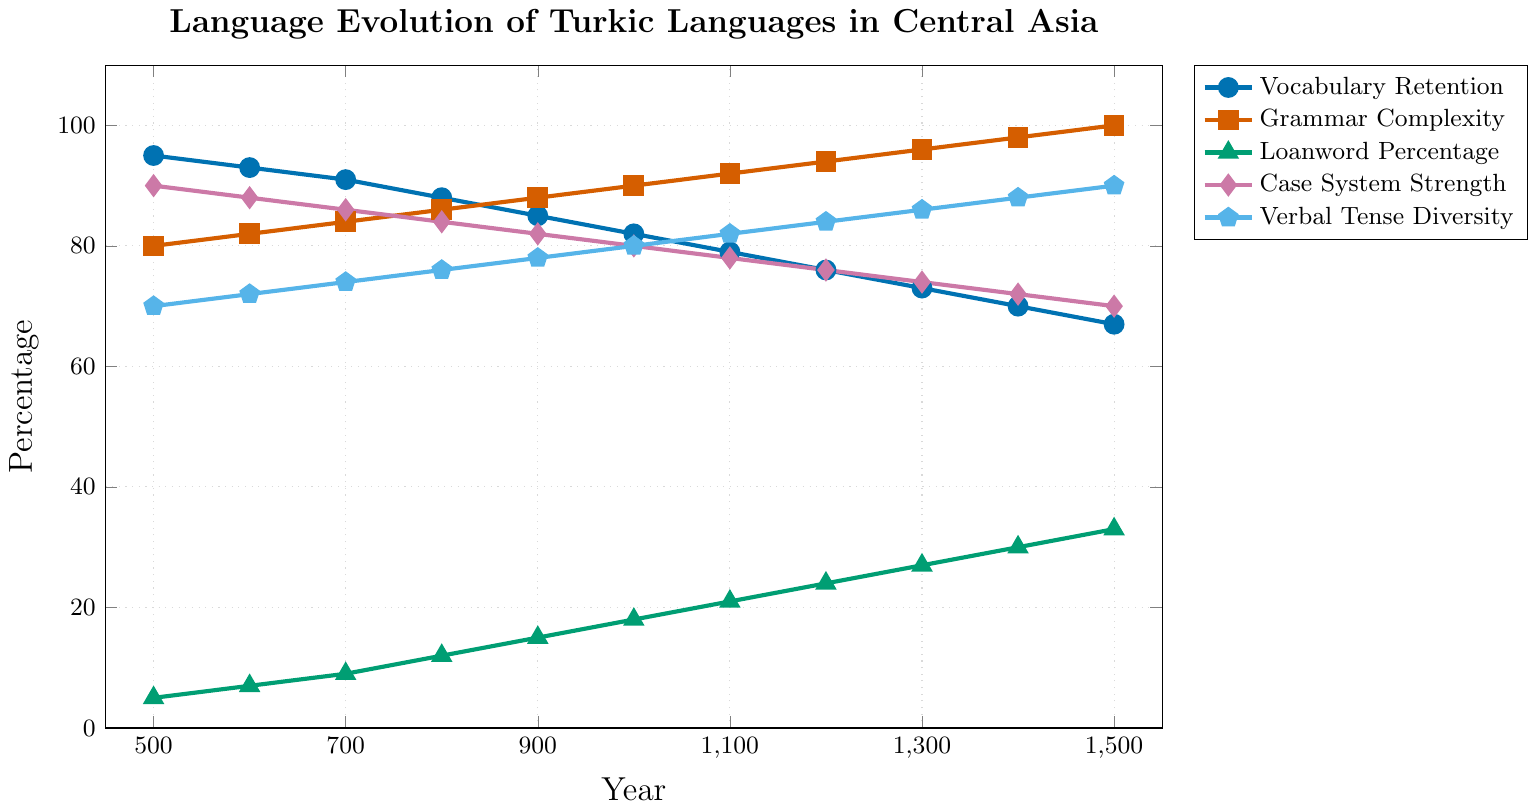What trend do you observe in the Grammar Complexity of Turkic languages from 500 CE to 1500 CE? The Grammar Complexity line starts at 80 in 500 CE and gradually increases to 100 by 1500 CE, showing a consistent upward trend.
Answer: Consistent increase Which aspect of the Turkic languages had the highest value in 500 CE and what was its value? Vocabulary Retention had the highest value in 500 CE, at 95%.
Answer: Vocabulary Retention, 95% In which year does the Vocabulary Retention drop below 80% for the first time? By examining the Vocabulary Retention line, it drops below 80% between 1100 CE and 1200 CE.
Answer: 1200 CE Which aspect shows the greatest increase from 500 CE to 1500 CE? Loanword Percentage increases from 5% in 500 CE to 33% in 1500 CE, a rise of 28%, which is the greatest among all aspects.
Answer: Loanword Percentage Compare the Case System Strength and Verbal Tense Diversity in 1000 CE. What are their values? In 1000 CE, Case System Strength is 80% and Verbal Tense Diversity is also 80%.
Answer: Both are 80% What is the overall trend in Vocabulary Retention from 500 CE to 1500 CE? The Vocabulary Retention line shows a consistent decline from 95% in 500 CE to 67% in 1500 CE.
Answer: Consistent decline What is the average Grammar Complexity for the years 500 CE, 1000 CE, and 1500 CE? Calculate the Grammar Complexity as (80+90+100)/3 = 90.
Answer: 90 How much did the Loanword Percentage increase between 700 CE and 1400 CE? The Loanword Percentage increased from 9% in 700 CE to 30% in 1400 CE, an increase of 21%.
Answer: 21% At what point does Verbal Tense Diversity exceed 80% for the first time? Verbal Tense Diversity exceeds 80% between 1000 CE and 1100 CE.
Answer: 1100 CE Which aspect remained most stable in terms of percentage change from 500 CE to 1500 CE? Case System Strength changes from 90% in 500 CE to 70% in 1500 CE, a decrease of 20%, which is the smallest percentage change among the aspects.
Answer: Case System Strength 